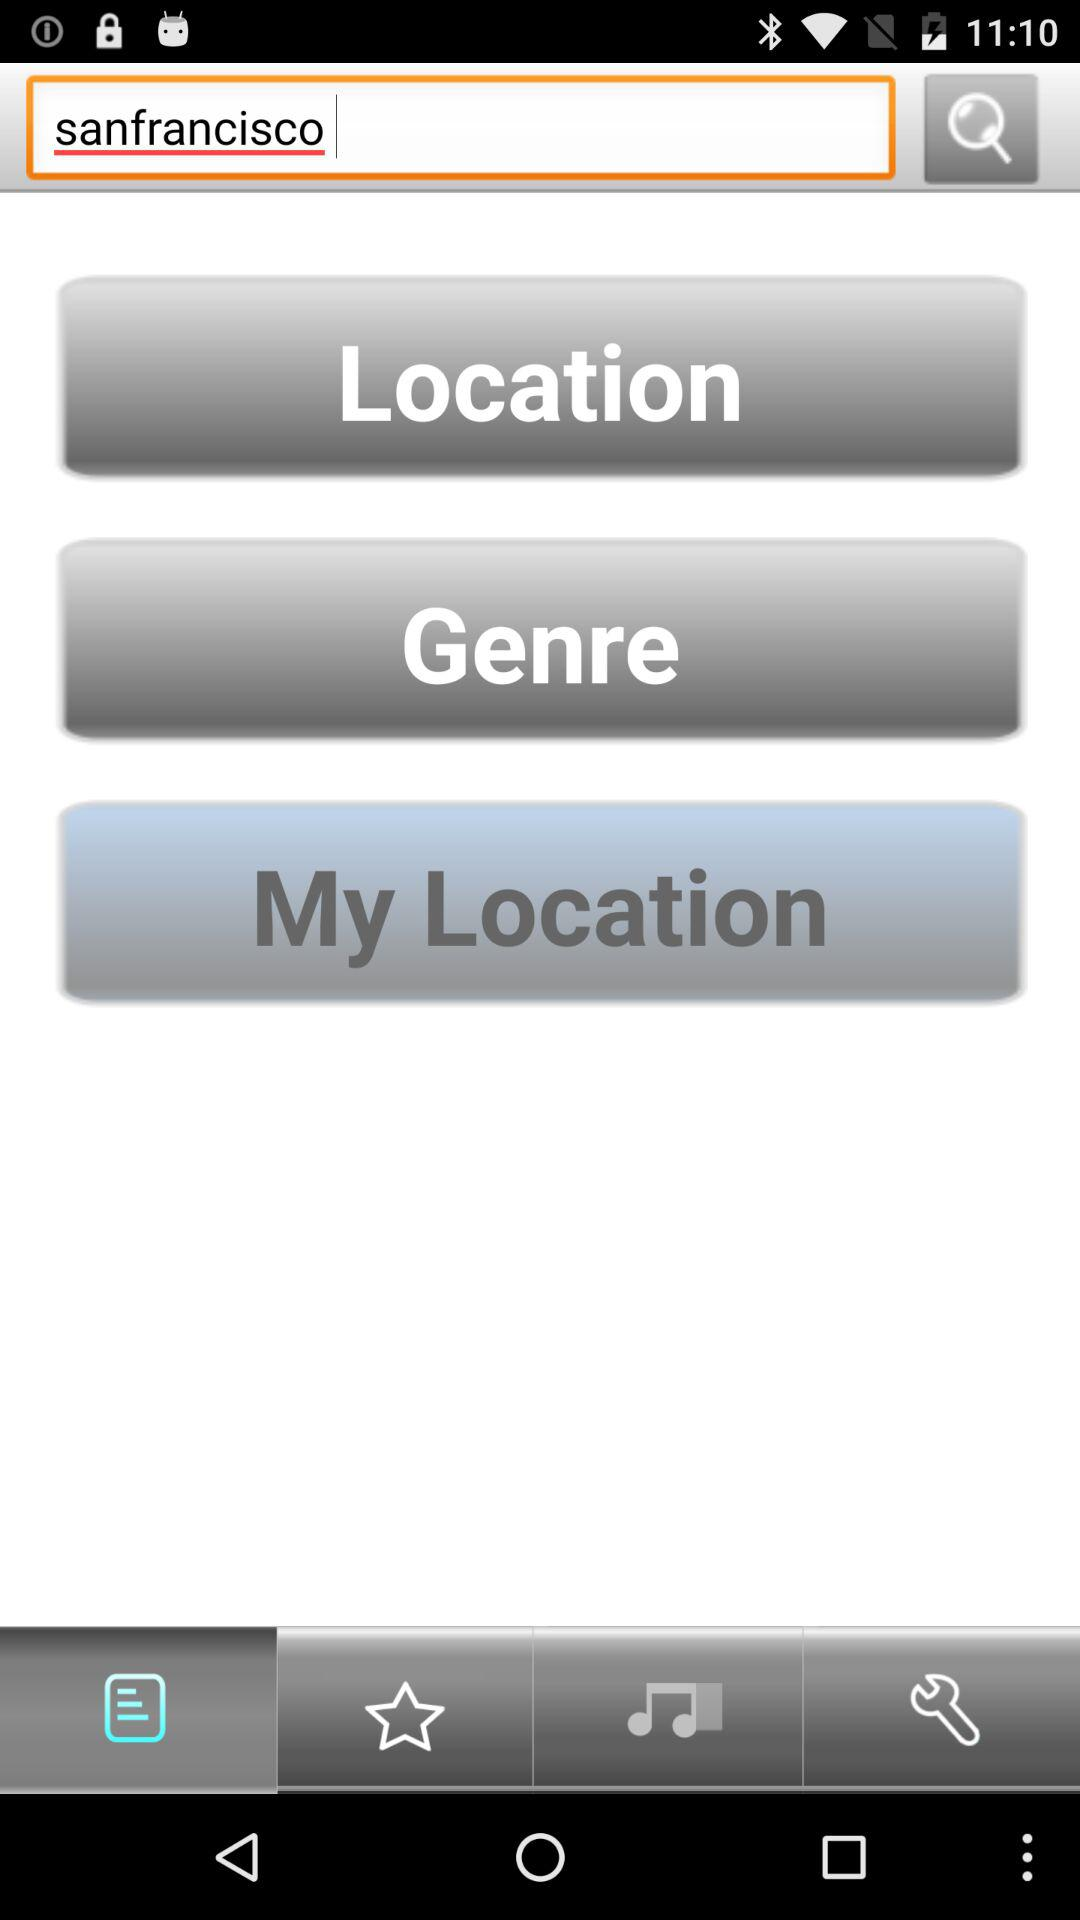What is the text input given to the search bar? The text input given to the search bar is San Francisco. 